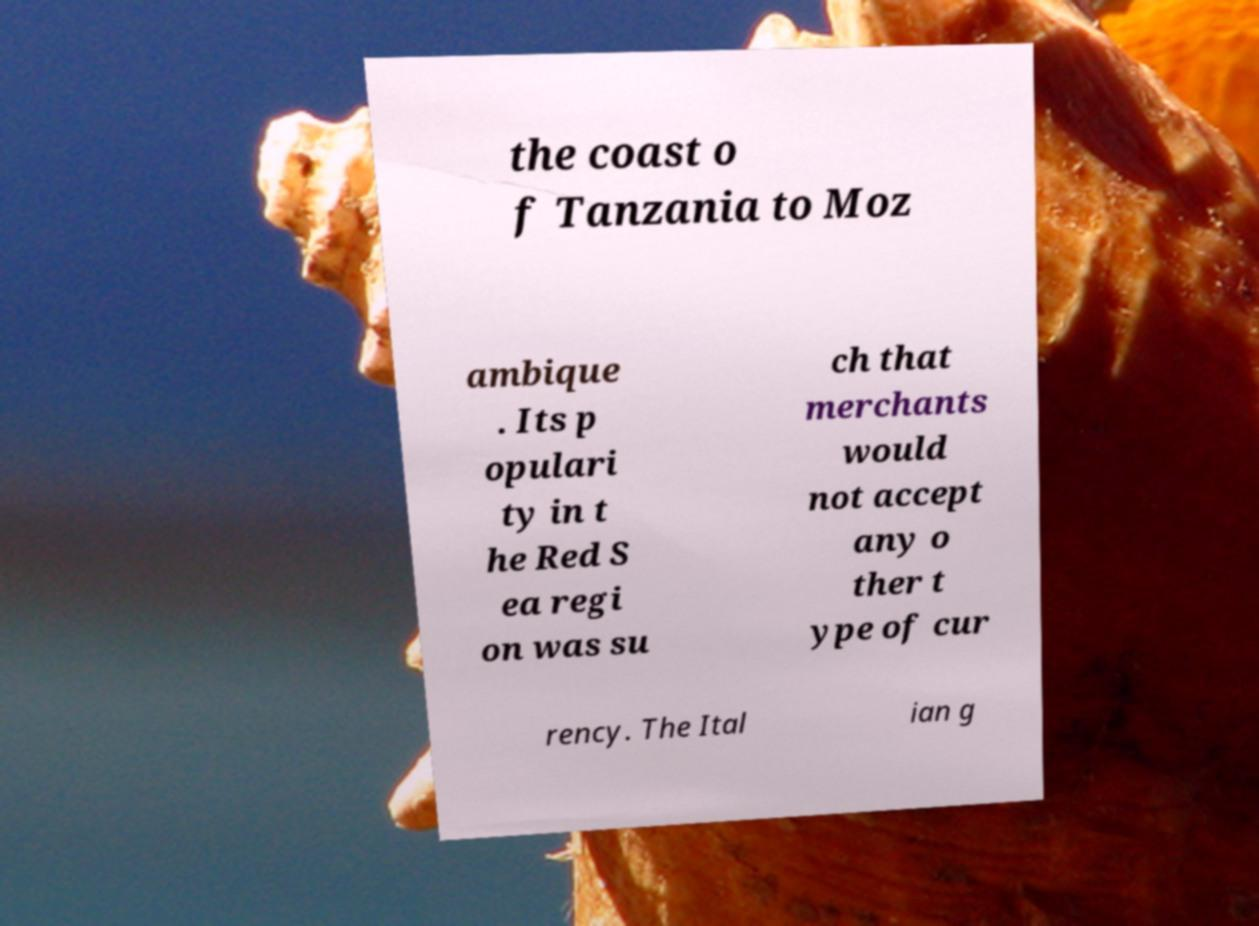Please identify and transcribe the text found in this image. the coast o f Tanzania to Moz ambique . Its p opulari ty in t he Red S ea regi on was su ch that merchants would not accept any o ther t ype of cur rency. The Ital ian g 